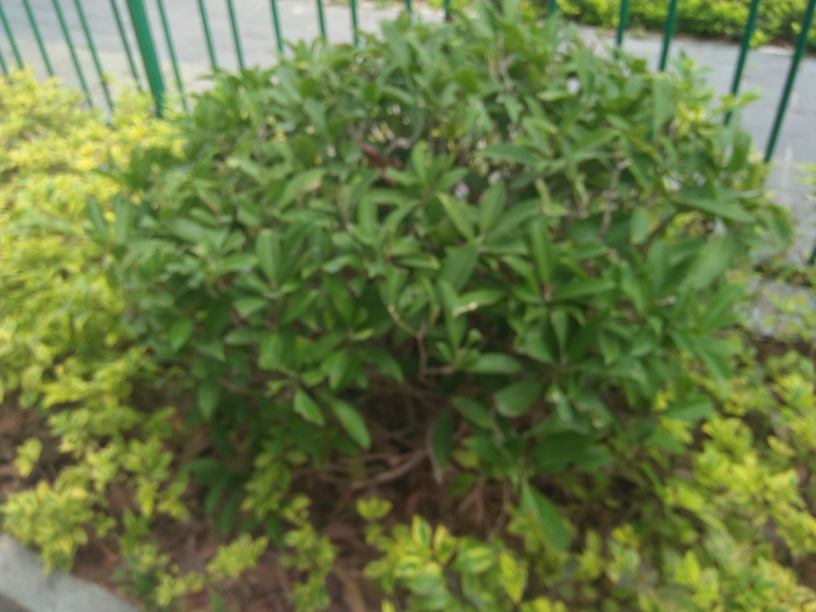What might be the cause of the poor image quality? The poor image quality could result from several factors, such as camera shake, incorrect focus settings, or movement during the shot. It might also be the result of taking a photograph in a hurried manner without properly composing the shot. 